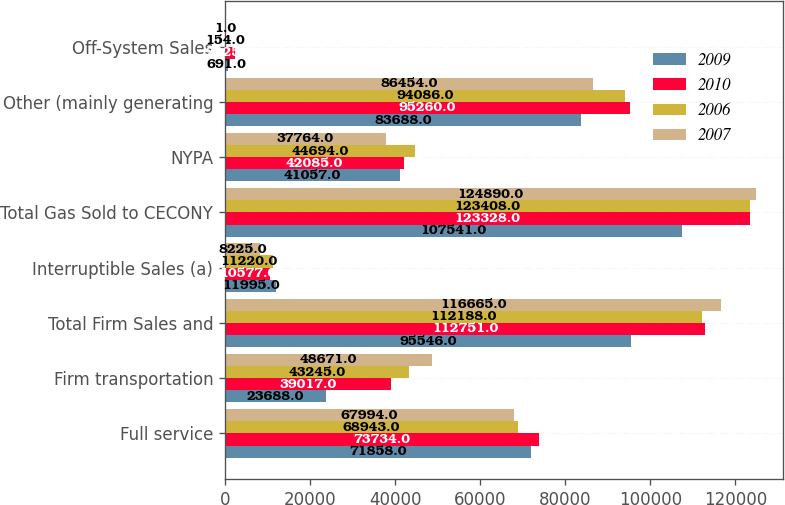<chart> <loc_0><loc_0><loc_500><loc_500><stacked_bar_chart><ecel><fcel>Full service<fcel>Firm transportation<fcel>Total Firm Sales and<fcel>Interruptible Sales (a)<fcel>Total Gas Sold to CECONY<fcel>NYPA<fcel>Other (mainly generating<fcel>Off-System Sales<nl><fcel>2009<fcel>71858<fcel>23688<fcel>95546<fcel>11995<fcel>107541<fcel>41057<fcel>83688<fcel>691<nl><fcel>2010<fcel>73734<fcel>39017<fcel>112751<fcel>10577<fcel>123328<fcel>42085<fcel>95260<fcel>2325<nl><fcel>2006<fcel>68943<fcel>43245<fcel>112188<fcel>11220<fcel>123408<fcel>44694<fcel>94086<fcel>154<nl><fcel>2007<fcel>67994<fcel>48671<fcel>116665<fcel>8225<fcel>124890<fcel>37764<fcel>86454<fcel>1<nl></chart> 